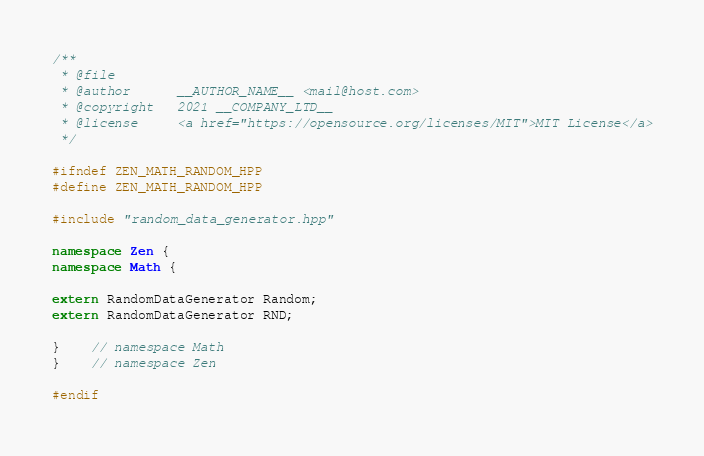Convert code to text. <code><loc_0><loc_0><loc_500><loc_500><_C++_>/**
 * @file
 * @author		__AUTHOR_NAME__ <mail@host.com>
 * @copyright	2021 __COMPANY_LTD__
 * @license		<a href="https://opensource.org/licenses/MIT">MIT License</a>
 */

#ifndef ZEN_MATH_RANDOM_HPP
#define ZEN_MATH_RANDOM_HPP

#include "random_data_generator.hpp"

namespace Zen {
namespace Math {

extern RandomDataGenerator Random;
extern RandomDataGenerator RND;

}	// namespace Math
}	// namespace Zen

#endif
</code> 